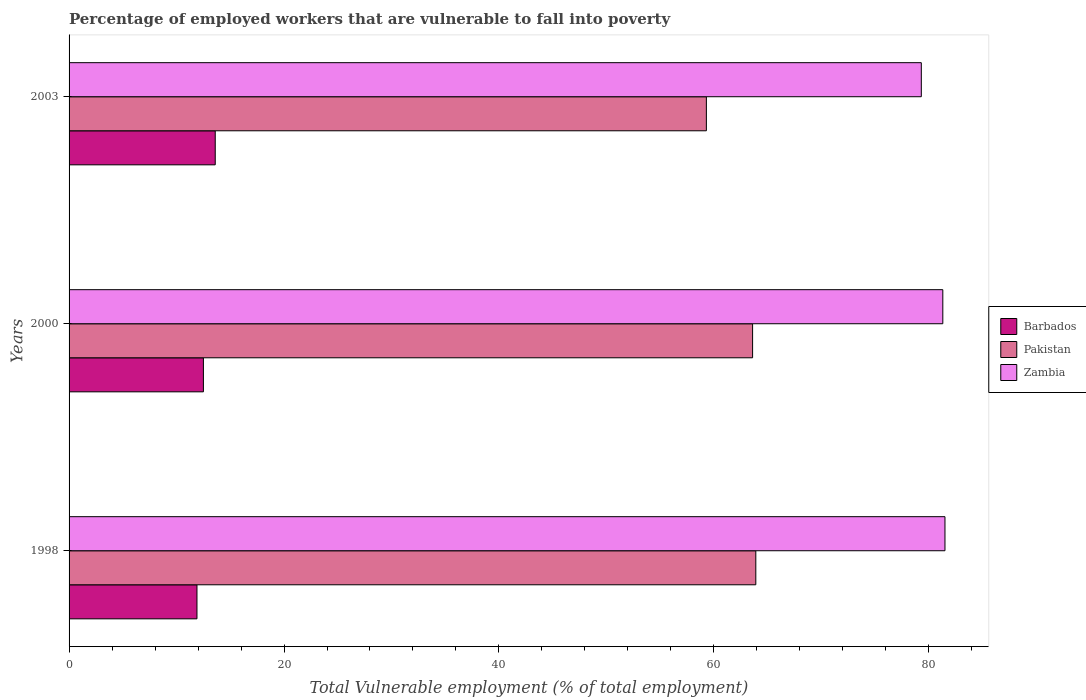How many different coloured bars are there?
Offer a very short reply. 3. How many bars are there on the 2nd tick from the bottom?
Keep it short and to the point. 3. What is the percentage of employed workers who are vulnerable to fall into poverty in Barbados in 2003?
Give a very brief answer. 13.6. Across all years, what is the maximum percentage of employed workers who are vulnerable to fall into poverty in Pakistan?
Ensure brevity in your answer.  63.9. Across all years, what is the minimum percentage of employed workers who are vulnerable to fall into poverty in Pakistan?
Provide a short and direct response. 59.3. What is the total percentage of employed workers who are vulnerable to fall into poverty in Pakistan in the graph?
Offer a terse response. 186.8. What is the difference between the percentage of employed workers who are vulnerable to fall into poverty in Pakistan in 1998 and the percentage of employed workers who are vulnerable to fall into poverty in Zambia in 2003?
Offer a very short reply. -15.4. What is the average percentage of employed workers who are vulnerable to fall into poverty in Barbados per year?
Make the answer very short. 12.67. In the year 1998, what is the difference between the percentage of employed workers who are vulnerable to fall into poverty in Zambia and percentage of employed workers who are vulnerable to fall into poverty in Barbados?
Give a very brief answer. 69.6. What is the ratio of the percentage of employed workers who are vulnerable to fall into poverty in Barbados in 2000 to that in 2003?
Your response must be concise. 0.92. What is the difference between the highest and the second highest percentage of employed workers who are vulnerable to fall into poverty in Barbados?
Provide a short and direct response. 1.1. What is the difference between the highest and the lowest percentage of employed workers who are vulnerable to fall into poverty in Barbados?
Keep it short and to the point. 1.7. In how many years, is the percentage of employed workers who are vulnerable to fall into poverty in Barbados greater than the average percentage of employed workers who are vulnerable to fall into poverty in Barbados taken over all years?
Offer a terse response. 1. What does the 1st bar from the top in 2003 represents?
Give a very brief answer. Zambia. What does the 2nd bar from the bottom in 2000 represents?
Offer a very short reply. Pakistan. How many bars are there?
Give a very brief answer. 9. Does the graph contain grids?
Provide a short and direct response. No. What is the title of the graph?
Make the answer very short. Percentage of employed workers that are vulnerable to fall into poverty. What is the label or title of the X-axis?
Your answer should be compact. Total Vulnerable employment (% of total employment). What is the Total Vulnerable employment (% of total employment) in Barbados in 1998?
Your answer should be very brief. 11.9. What is the Total Vulnerable employment (% of total employment) of Pakistan in 1998?
Ensure brevity in your answer.  63.9. What is the Total Vulnerable employment (% of total employment) in Zambia in 1998?
Your response must be concise. 81.5. What is the Total Vulnerable employment (% of total employment) in Pakistan in 2000?
Provide a succinct answer. 63.6. What is the Total Vulnerable employment (% of total employment) in Zambia in 2000?
Make the answer very short. 81.3. What is the Total Vulnerable employment (% of total employment) in Barbados in 2003?
Keep it short and to the point. 13.6. What is the Total Vulnerable employment (% of total employment) in Pakistan in 2003?
Make the answer very short. 59.3. What is the Total Vulnerable employment (% of total employment) in Zambia in 2003?
Provide a short and direct response. 79.3. Across all years, what is the maximum Total Vulnerable employment (% of total employment) of Barbados?
Your response must be concise. 13.6. Across all years, what is the maximum Total Vulnerable employment (% of total employment) of Pakistan?
Offer a terse response. 63.9. Across all years, what is the maximum Total Vulnerable employment (% of total employment) of Zambia?
Provide a succinct answer. 81.5. Across all years, what is the minimum Total Vulnerable employment (% of total employment) of Barbados?
Make the answer very short. 11.9. Across all years, what is the minimum Total Vulnerable employment (% of total employment) in Pakistan?
Make the answer very short. 59.3. Across all years, what is the minimum Total Vulnerable employment (% of total employment) in Zambia?
Offer a very short reply. 79.3. What is the total Total Vulnerable employment (% of total employment) in Pakistan in the graph?
Offer a terse response. 186.8. What is the total Total Vulnerable employment (% of total employment) of Zambia in the graph?
Provide a succinct answer. 242.1. What is the difference between the Total Vulnerable employment (% of total employment) of Pakistan in 1998 and that in 2003?
Offer a terse response. 4.6. What is the difference between the Total Vulnerable employment (% of total employment) in Barbados in 2000 and that in 2003?
Your answer should be compact. -1.1. What is the difference between the Total Vulnerable employment (% of total employment) in Zambia in 2000 and that in 2003?
Your answer should be compact. 2. What is the difference between the Total Vulnerable employment (% of total employment) of Barbados in 1998 and the Total Vulnerable employment (% of total employment) of Pakistan in 2000?
Your answer should be very brief. -51.7. What is the difference between the Total Vulnerable employment (% of total employment) in Barbados in 1998 and the Total Vulnerable employment (% of total employment) in Zambia in 2000?
Keep it short and to the point. -69.4. What is the difference between the Total Vulnerable employment (% of total employment) of Pakistan in 1998 and the Total Vulnerable employment (% of total employment) of Zambia in 2000?
Your response must be concise. -17.4. What is the difference between the Total Vulnerable employment (% of total employment) of Barbados in 1998 and the Total Vulnerable employment (% of total employment) of Pakistan in 2003?
Ensure brevity in your answer.  -47.4. What is the difference between the Total Vulnerable employment (% of total employment) of Barbados in 1998 and the Total Vulnerable employment (% of total employment) of Zambia in 2003?
Your answer should be very brief. -67.4. What is the difference between the Total Vulnerable employment (% of total employment) of Pakistan in 1998 and the Total Vulnerable employment (% of total employment) of Zambia in 2003?
Offer a very short reply. -15.4. What is the difference between the Total Vulnerable employment (% of total employment) of Barbados in 2000 and the Total Vulnerable employment (% of total employment) of Pakistan in 2003?
Your answer should be compact. -46.8. What is the difference between the Total Vulnerable employment (% of total employment) of Barbados in 2000 and the Total Vulnerable employment (% of total employment) of Zambia in 2003?
Make the answer very short. -66.8. What is the difference between the Total Vulnerable employment (% of total employment) of Pakistan in 2000 and the Total Vulnerable employment (% of total employment) of Zambia in 2003?
Provide a succinct answer. -15.7. What is the average Total Vulnerable employment (% of total employment) of Barbados per year?
Offer a terse response. 12.67. What is the average Total Vulnerable employment (% of total employment) of Pakistan per year?
Your answer should be compact. 62.27. What is the average Total Vulnerable employment (% of total employment) in Zambia per year?
Provide a short and direct response. 80.7. In the year 1998, what is the difference between the Total Vulnerable employment (% of total employment) in Barbados and Total Vulnerable employment (% of total employment) in Pakistan?
Give a very brief answer. -52. In the year 1998, what is the difference between the Total Vulnerable employment (% of total employment) of Barbados and Total Vulnerable employment (% of total employment) of Zambia?
Your answer should be compact. -69.6. In the year 1998, what is the difference between the Total Vulnerable employment (% of total employment) in Pakistan and Total Vulnerable employment (% of total employment) in Zambia?
Your answer should be very brief. -17.6. In the year 2000, what is the difference between the Total Vulnerable employment (% of total employment) in Barbados and Total Vulnerable employment (% of total employment) in Pakistan?
Your response must be concise. -51.1. In the year 2000, what is the difference between the Total Vulnerable employment (% of total employment) in Barbados and Total Vulnerable employment (% of total employment) in Zambia?
Keep it short and to the point. -68.8. In the year 2000, what is the difference between the Total Vulnerable employment (% of total employment) in Pakistan and Total Vulnerable employment (% of total employment) in Zambia?
Ensure brevity in your answer.  -17.7. In the year 2003, what is the difference between the Total Vulnerable employment (% of total employment) of Barbados and Total Vulnerable employment (% of total employment) of Pakistan?
Your response must be concise. -45.7. In the year 2003, what is the difference between the Total Vulnerable employment (% of total employment) in Barbados and Total Vulnerable employment (% of total employment) in Zambia?
Your response must be concise. -65.7. What is the ratio of the Total Vulnerable employment (% of total employment) of Zambia in 1998 to that in 2000?
Offer a terse response. 1. What is the ratio of the Total Vulnerable employment (% of total employment) in Barbados in 1998 to that in 2003?
Keep it short and to the point. 0.88. What is the ratio of the Total Vulnerable employment (% of total employment) of Pakistan in 1998 to that in 2003?
Provide a short and direct response. 1.08. What is the ratio of the Total Vulnerable employment (% of total employment) in Zambia in 1998 to that in 2003?
Make the answer very short. 1.03. What is the ratio of the Total Vulnerable employment (% of total employment) in Barbados in 2000 to that in 2003?
Your answer should be compact. 0.92. What is the ratio of the Total Vulnerable employment (% of total employment) in Pakistan in 2000 to that in 2003?
Your answer should be compact. 1.07. What is the ratio of the Total Vulnerable employment (% of total employment) in Zambia in 2000 to that in 2003?
Ensure brevity in your answer.  1.03. What is the difference between the highest and the second highest Total Vulnerable employment (% of total employment) of Barbados?
Make the answer very short. 1.1. What is the difference between the highest and the second highest Total Vulnerable employment (% of total employment) in Pakistan?
Give a very brief answer. 0.3. What is the difference between the highest and the second highest Total Vulnerable employment (% of total employment) in Zambia?
Give a very brief answer. 0.2. 